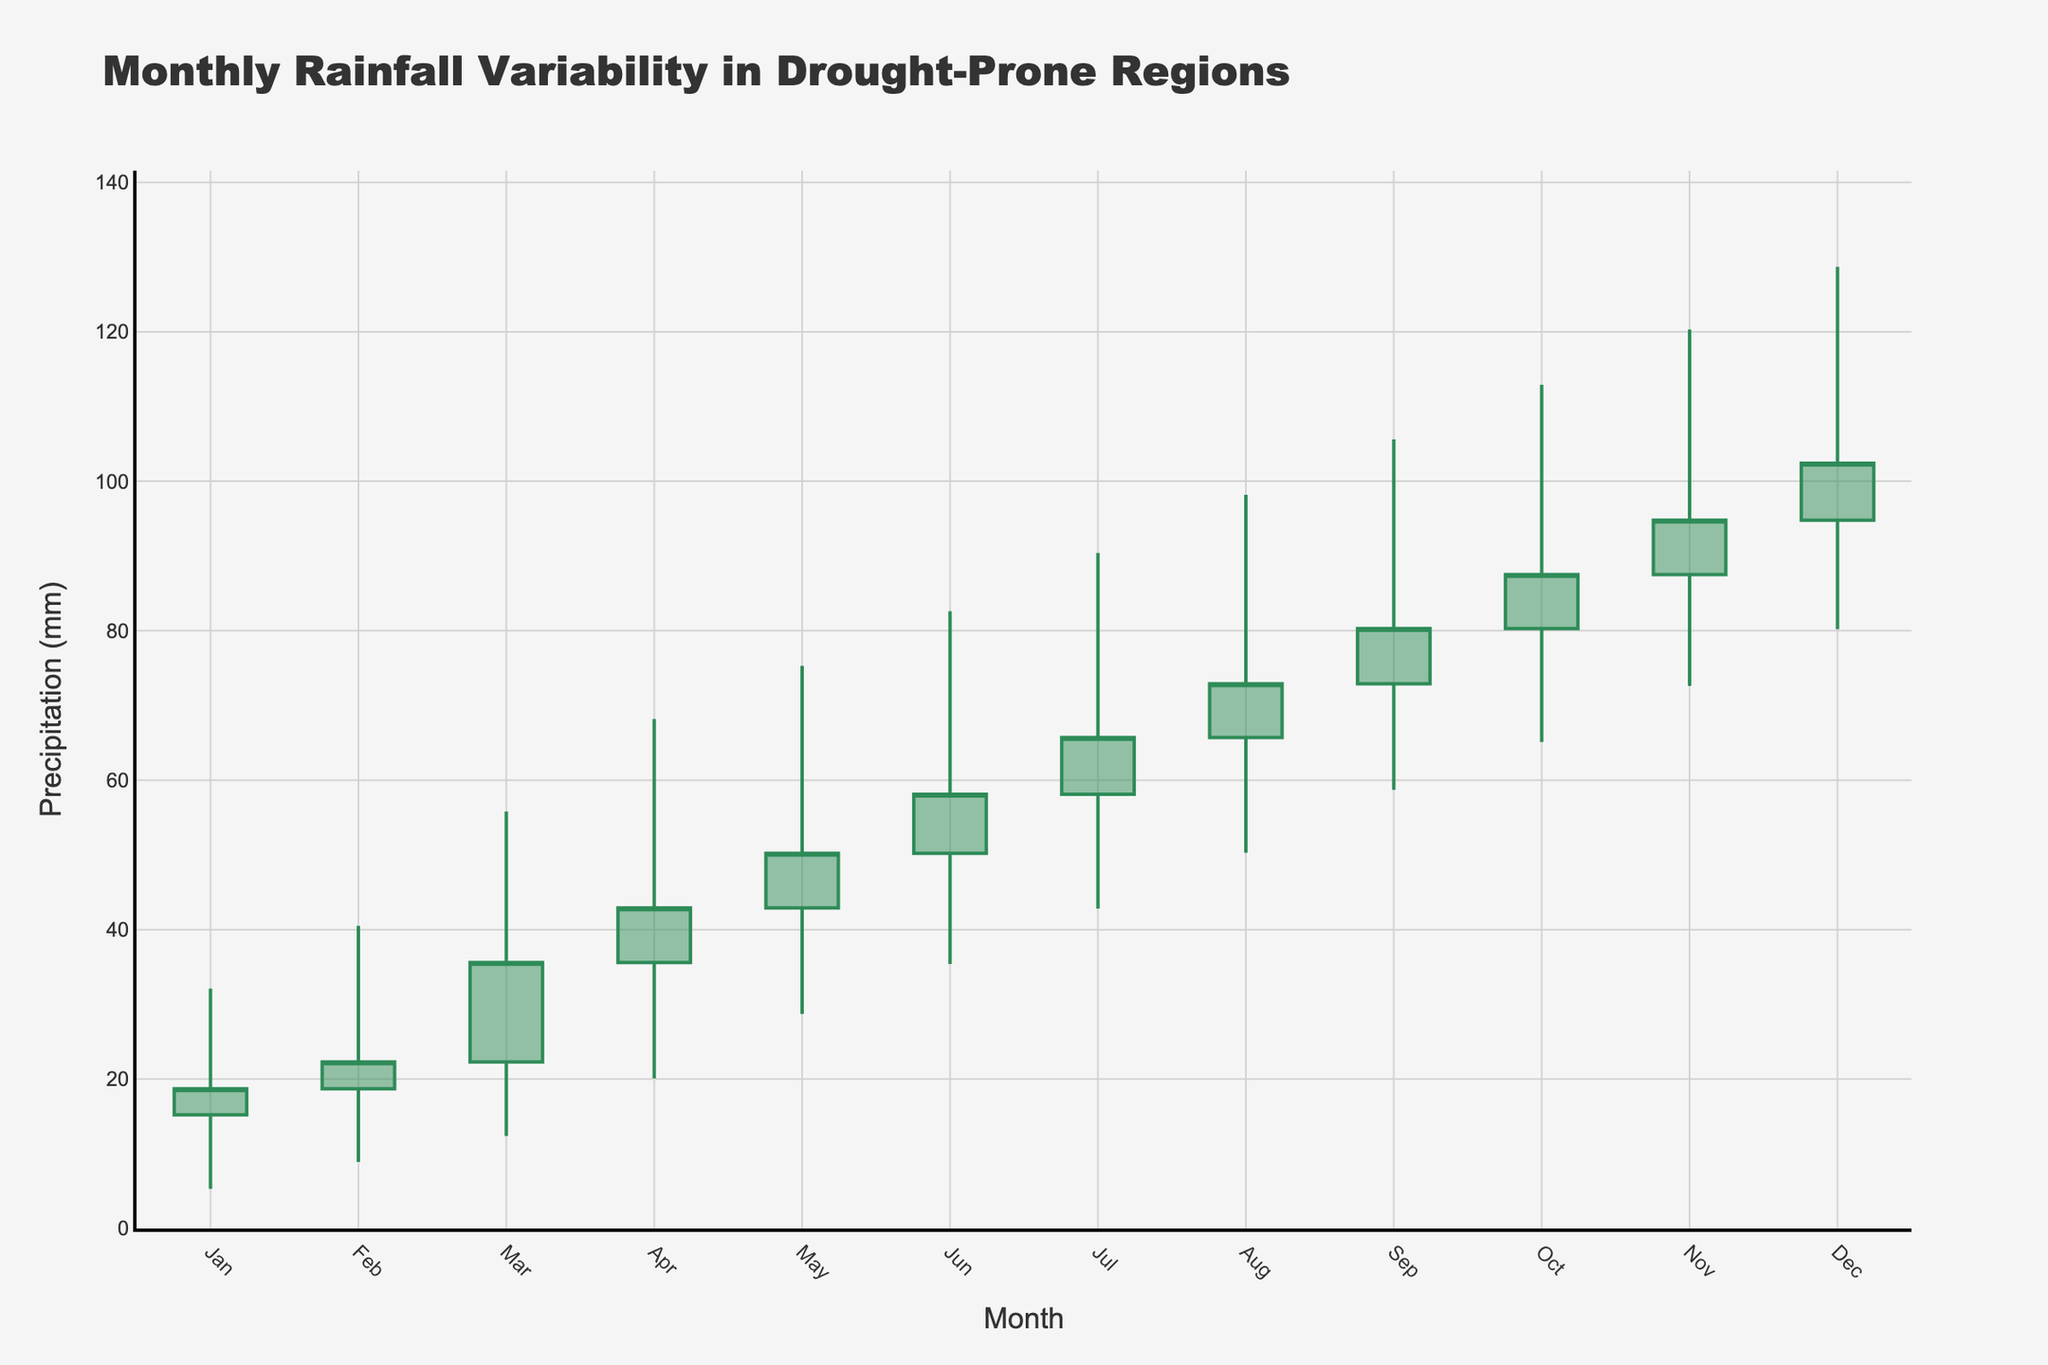What is the title of the figure? The title is located at the top of the plot and gives an overall description of the data presented. It is often written in larger, bold font.
Answer: Monthly Rainfall Variability in Drought-Prone Regions In which month is the highest rainfall recorded? The highest rainfall for each month is represented by the 'High' value in the OHLC chart. By scanning vertically for the highest peak, we see that December records the highest rainfall.
Answer: December What is the range of precipitation values for August? The range is calculated by subtracting the 'Low' value from the 'High' value for August. High is 98.2 mm and Low is 50.3 mm, giving a difference of 98.2 - 50.3.
Answer: 47.9 mm Between which two months does the 'Close' value show the greatest increase? To find this, calculate the difference in 'Close' values between each consecutive pair of months and identify the pair with the maximum positive difference. July to August shows the greatest increase of 72.9 - 65.7.
Answer: July to August What is the average 'Close' value for the first quarter (Jan, Feb, Mar)? Sum the 'Close' values for January, February, and March, then divide by 3. (18.7 + 22.3 + 35.6) / 3
Answer: 25.53 mm Which month has the widest range of monthly precipitation values? Compare the difference between 'High' and 'Low' values for all months and identify the month with the greatest difference. November has the widest range with values between 120.3 (High) and 72.6 (Low).
Answer: November In which month is the lowest 'Low' value observed, and what is the value? Scan the 'Low' values for each month to find the minimum, which occurs in January.
Answer: January, 5.3 mm How much did the 'Open' value increase from January to December? Subtract the 'Open' value of January from that of December (94.8 - 15.2).
Answer: 79.6 mm 